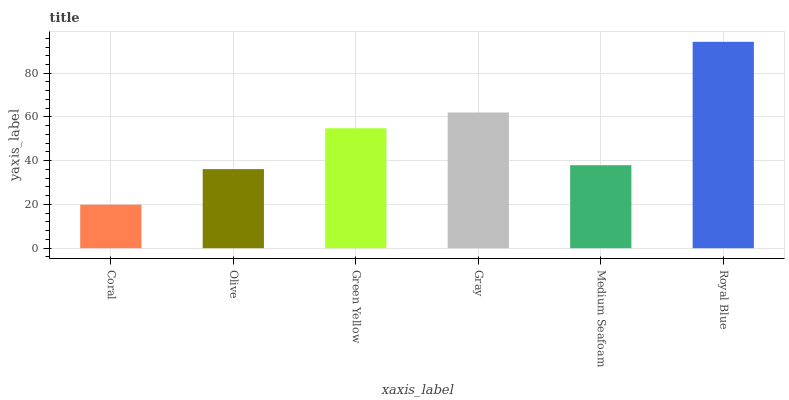Is Olive the minimum?
Answer yes or no. No. Is Olive the maximum?
Answer yes or no. No. Is Olive greater than Coral?
Answer yes or no. Yes. Is Coral less than Olive?
Answer yes or no. Yes. Is Coral greater than Olive?
Answer yes or no. No. Is Olive less than Coral?
Answer yes or no. No. Is Green Yellow the high median?
Answer yes or no. Yes. Is Medium Seafoam the low median?
Answer yes or no. Yes. Is Medium Seafoam the high median?
Answer yes or no. No. Is Royal Blue the low median?
Answer yes or no. No. 